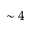<formula> <loc_0><loc_0><loc_500><loc_500>\sim 4</formula> 